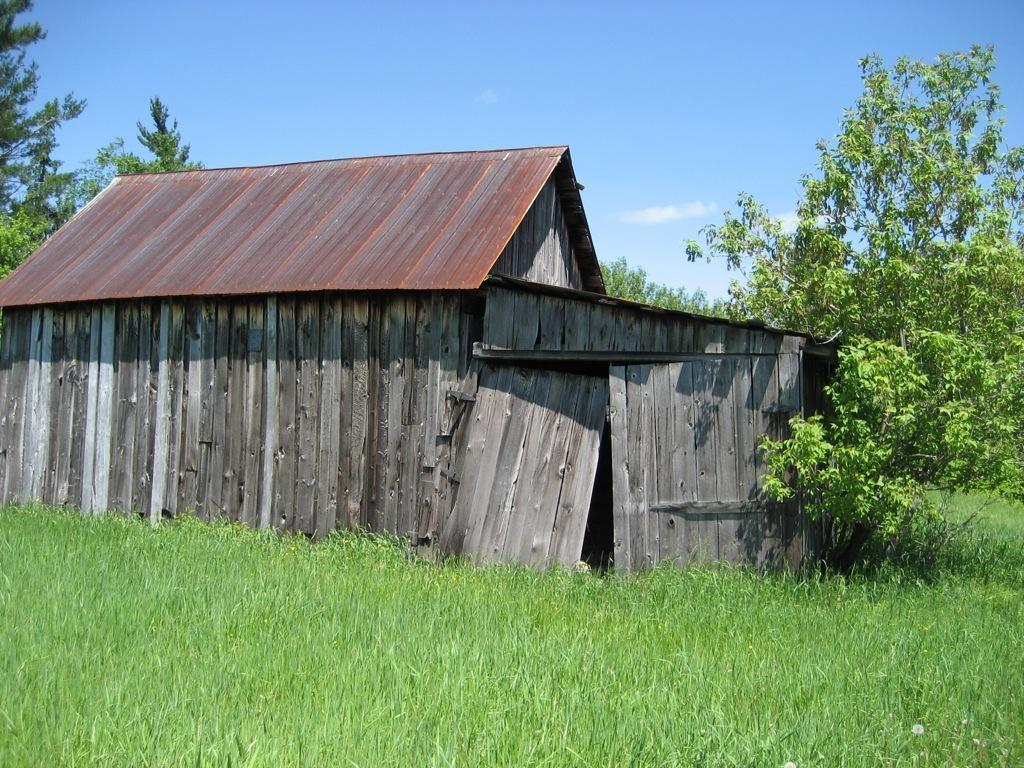How would you summarize this image in a sentence or two? In the image in the center, we can see the sky, clouds, trees, grass and one wooden house. 